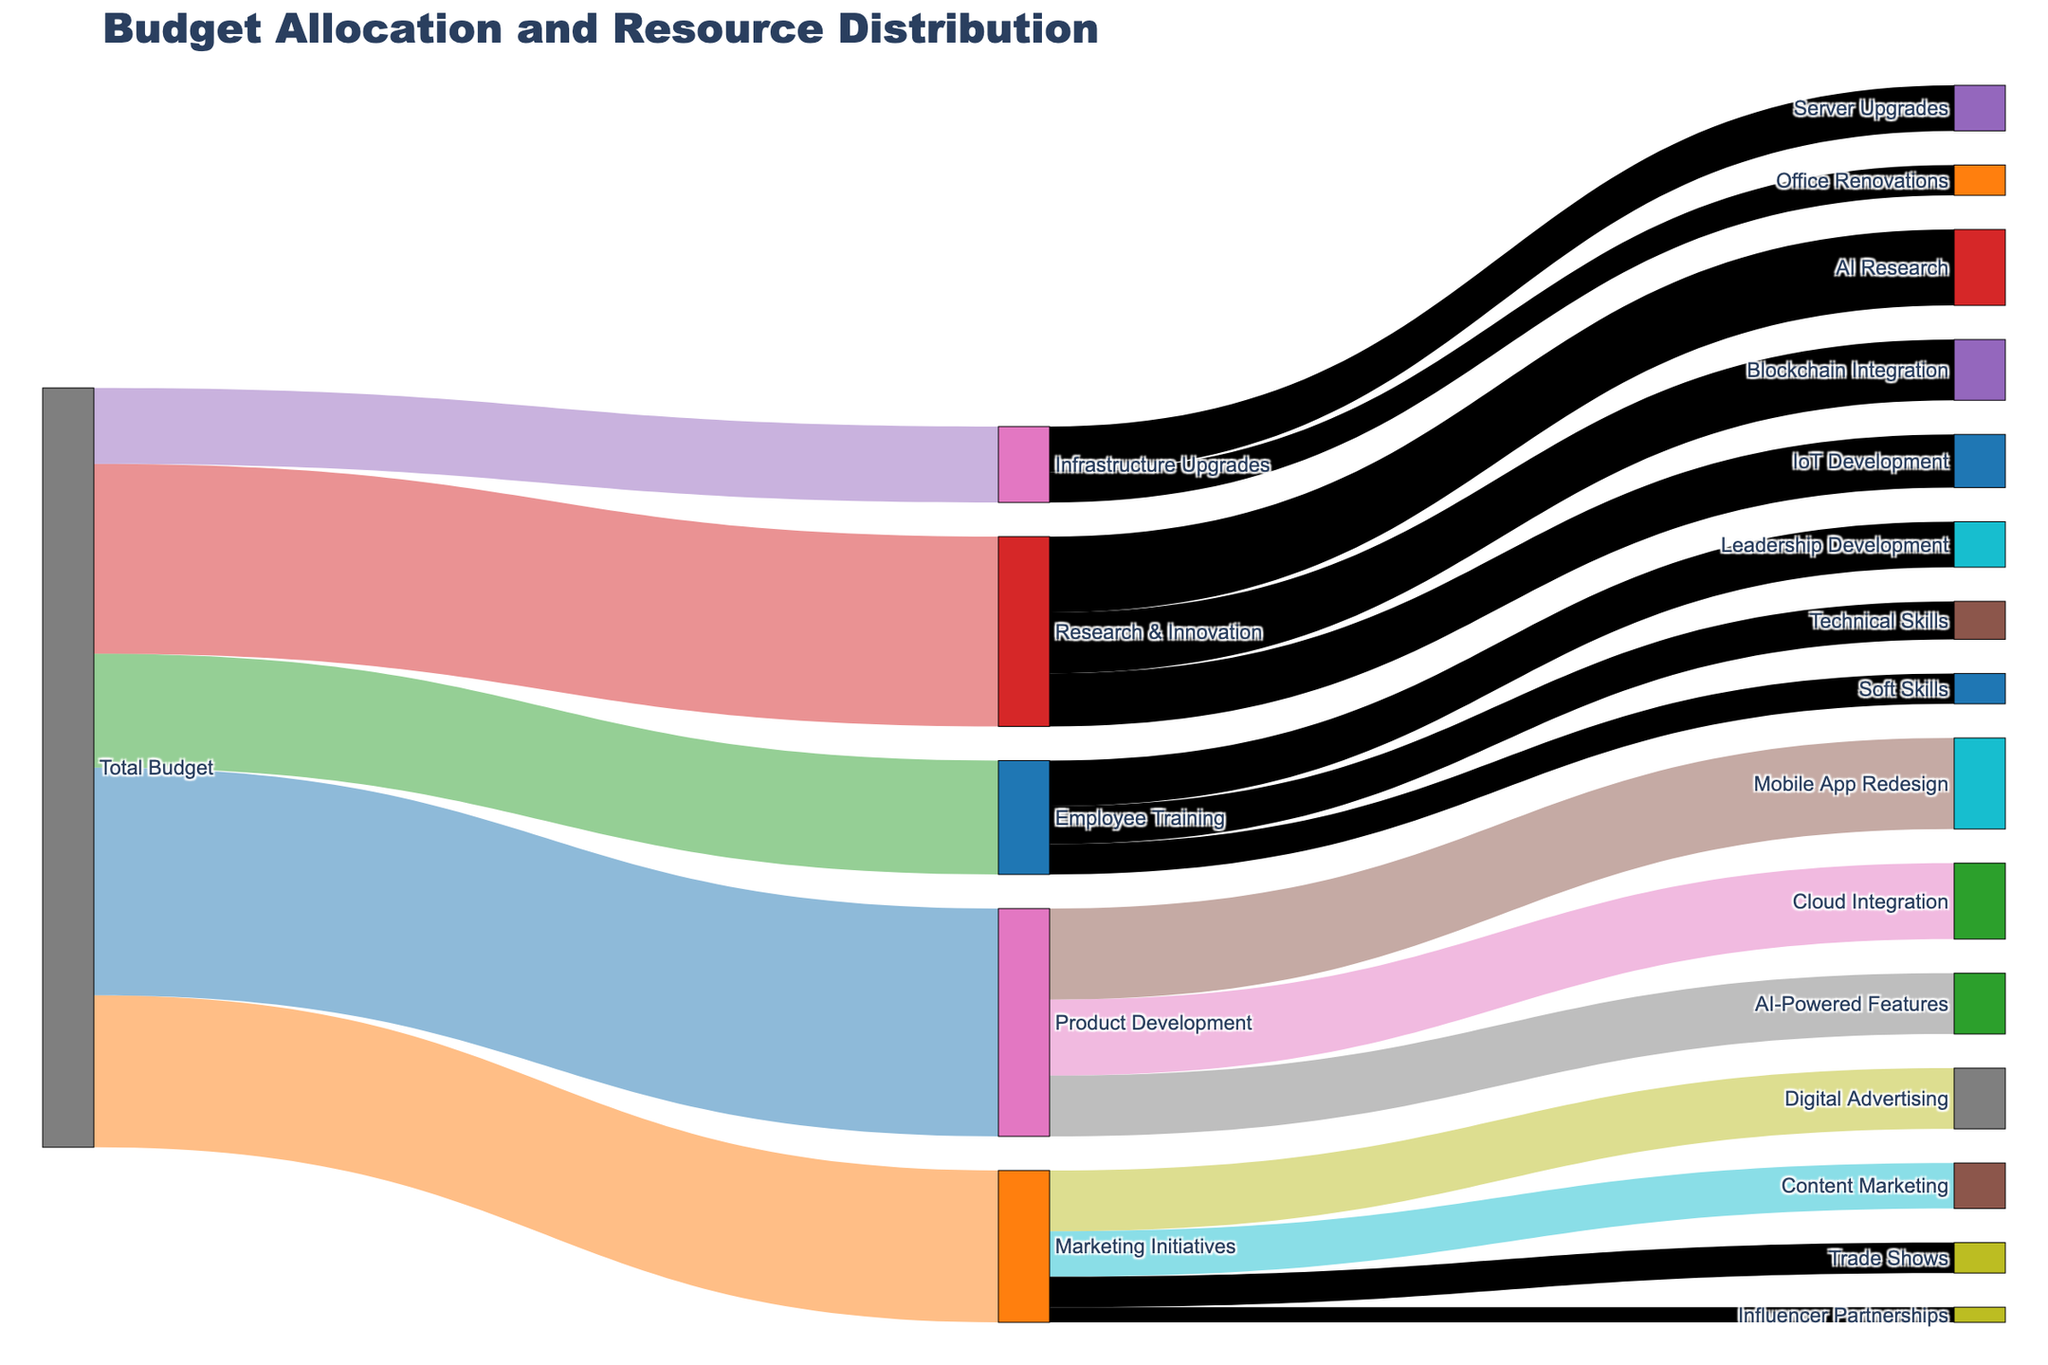What is the largest single allocation from the Total Budget? The largest single allocation from the Total Budget can be identified by looking at the values associated with the "Total Budget" node and finding the maximum. The values are: Product Development (3000000), Marketing Initiatives (2000000), Employee Training (1500000), Research & Innovation (2500000), Infrastructure Upgrades (1000000). The highest of these is 3000000 to Product Development.
Answer: 3000000 to Product Development How many initiatives are funded under Product Development? To find the number of initiatives funded under Product Development, count the connections originating from the Product Development node. These are Mobile App Redesign, Cloud Integration, and AI-Powered Features.
Answer: 3 Which category within Employee Training receives the smallest allocation? Within Employee Training, the connected values are Leadership Development (600000), Technical Skills (500000), and Soft Skills (400000). The smallest allocation among these is 400000 to Soft Skills.
Answer: Soft Skills What is the total budget allocation for Marketing Initiatives? Sum the allocations under Marketing Initiatives: Digital Advertising (800000) + Content Marketing (600000) + Trade Shows (400000) + Influencer Partnerships (200000). The total is 800000 + 600000 + 400000 + 200000 = 2000000.
Answer: 2000000 Which project under Research & Innovation gets the least amount of funding? The projects under Research & Innovation are AI Research (1000000), Blockchain Integration (800000), and IoT Development (700000). The project with the least funding is IoT Development with 700000.
Answer: IoT Development How does the allocation for AI-Powered Features compare to Digital Advertising? The allocation for AI-Powered Features is 800000 and for Digital Advertising is 800000. Both have equal allocations of 800000.
Answer: They are equal Which initiative under Infrastructure Upgrades receives more funding? Under Infrastructure Upgrades, the allocations are Server Upgrades (600000) and Office Renovations (400000). Server Upgrades receive more funding with 600000.
Answer: Server Upgrades Compare the total allocations for Product Development and Employee Training. Which is greater? The total for Product Development is 3000000 and for Employee Training is 1500000. Product Development has a greater total allocation.
Answer: Product Development Which node has the most number of outgoing links? The nodes are: Total Budget (5), Product Development (3), Marketing Initiatives (4), Employee Training (3), Research & Innovation (3), Infrastructure Upgrades (2). The node with the most outgoing links is Total Budget with 5.
Answer: Total Budget 